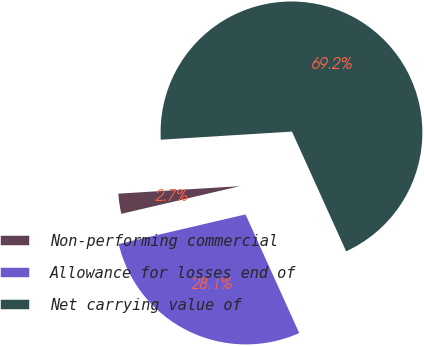<chart> <loc_0><loc_0><loc_500><loc_500><pie_chart><fcel>Non-performing commercial<fcel>Allowance for losses end of<fcel>Net carrying value of<nl><fcel>2.67%<fcel>28.11%<fcel>69.22%<nl></chart> 